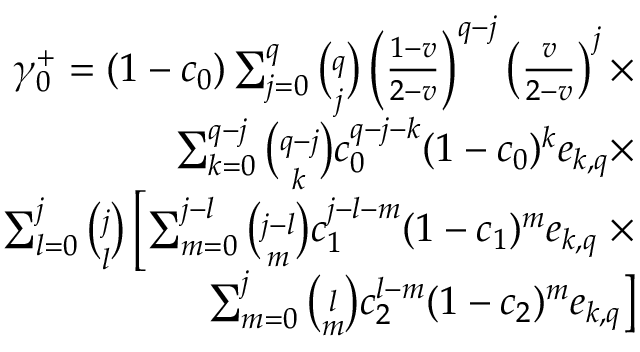<formula> <loc_0><loc_0><loc_500><loc_500>\begin{array} { r } { \gamma _ { 0 } ^ { + } = ( 1 - c _ { 0 } ) \sum _ { j = 0 } ^ { q } { \binom { q } { j } } \left ( \frac { 1 - v } { 2 - v } \right ) ^ { q - j } \left ( \frac { v } { 2 - v } \right ) ^ { j } \times } \\ { \sum _ { k = 0 } ^ { q - j } { \binom { q - j } { k } } c _ { 0 } ^ { q - j - k } ( 1 - c _ { 0 } ) ^ { k } e _ { k , q } \times } \\ { \sum _ { l = 0 } ^ { j } { \binom { j } { l } } \left [ \sum _ { m = 0 } ^ { j - l } { \binom { j - l } { m } } c _ { 1 } ^ { j - l - m } ( 1 - c _ { 1 } ) ^ { m } e _ { k , q } \times } \\ { \sum _ { m = 0 } ^ { j } { \binom { l } { m } } c _ { 2 } ^ { l - m } ( 1 - c _ { 2 } ) ^ { m } e _ { k , q } \right ] } \end{array}</formula> 